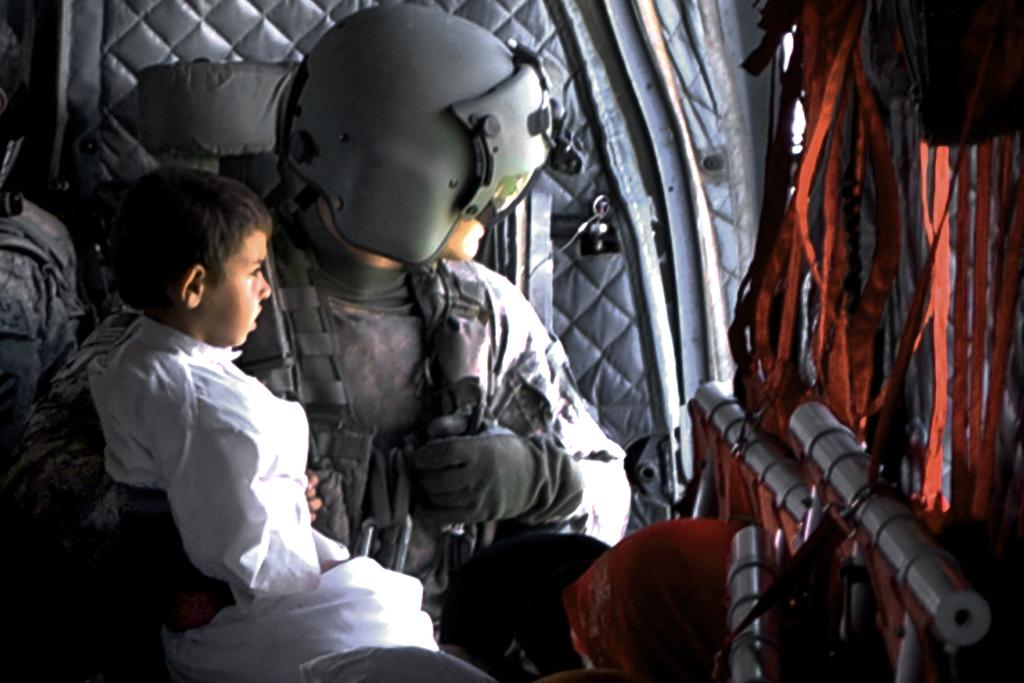What is the primary action of the person in the image? The person is sitting in the image. What is the person holding while sitting? The person is holding a baby. What type of marble is being used to create a painting in the image? There is no marble or painting present in the image; it features a person sitting and holding a baby. Where is the person sitting in the image? The location is not mentioned in the provided facts, so we cannot determine where the person is sitting. 